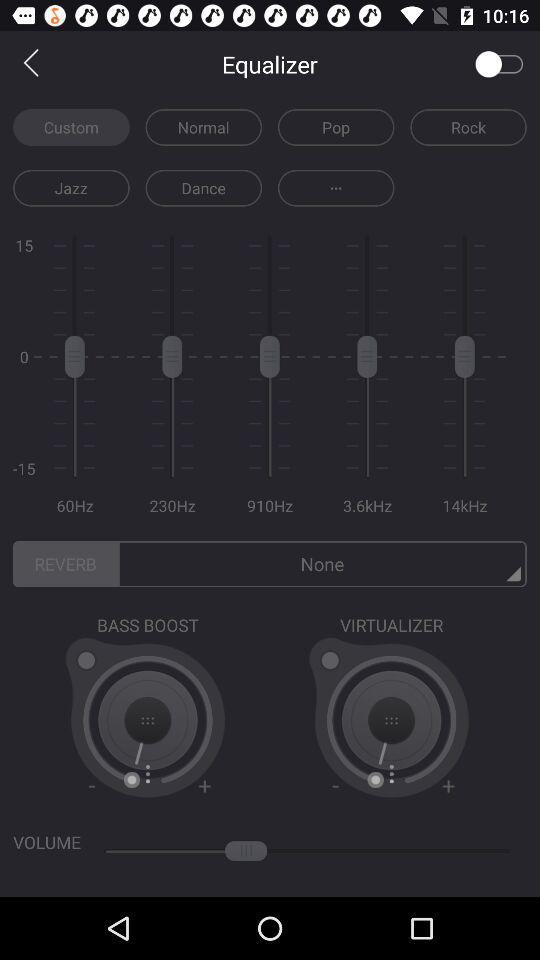What option has been selected? The selected option is "Custom". 